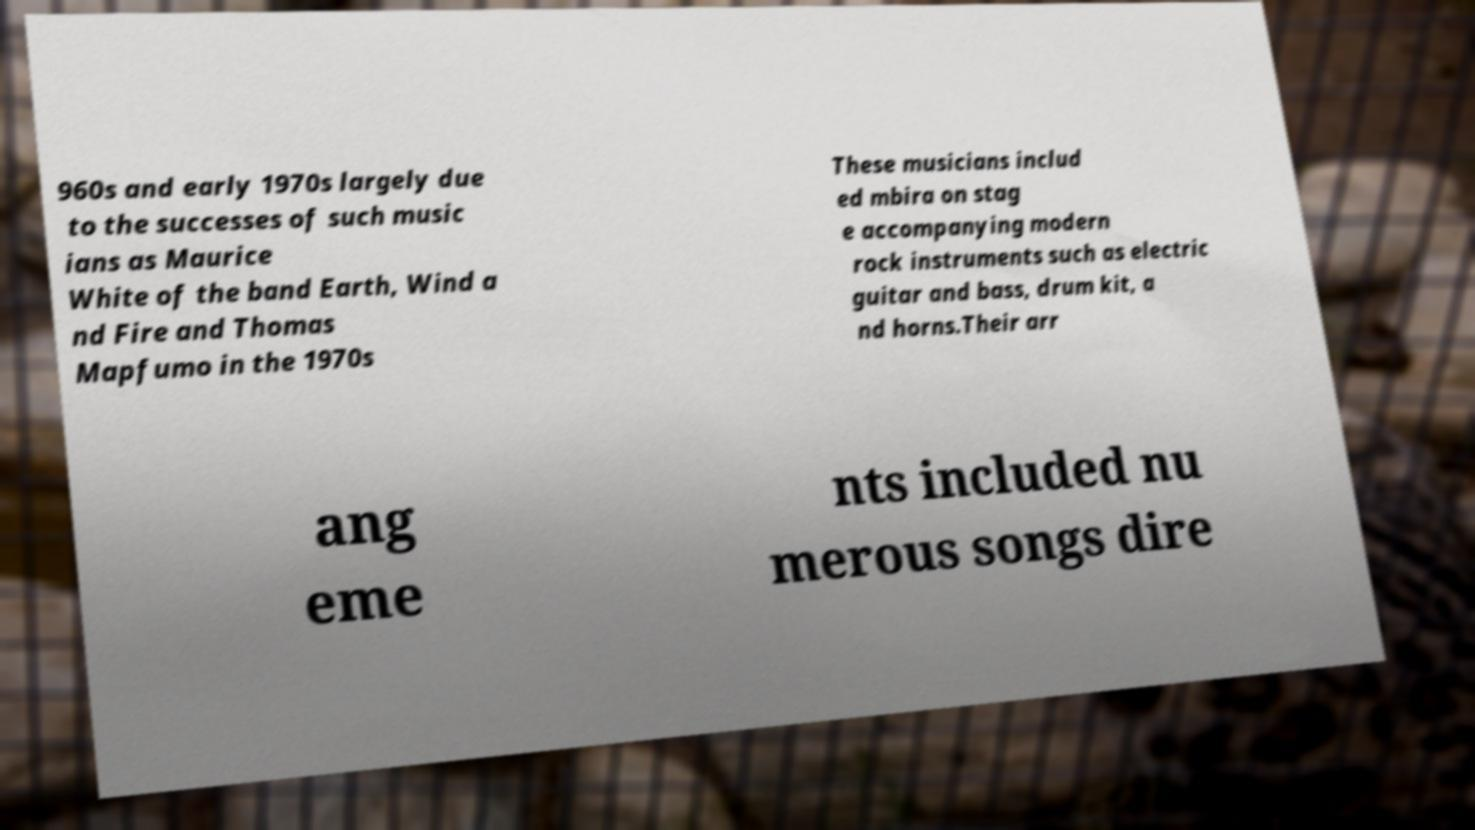Could you assist in decoding the text presented in this image and type it out clearly? 960s and early 1970s largely due to the successes of such music ians as Maurice White of the band Earth, Wind a nd Fire and Thomas Mapfumo in the 1970s These musicians includ ed mbira on stag e accompanying modern rock instruments such as electric guitar and bass, drum kit, a nd horns.Their arr ang eme nts included nu merous songs dire 